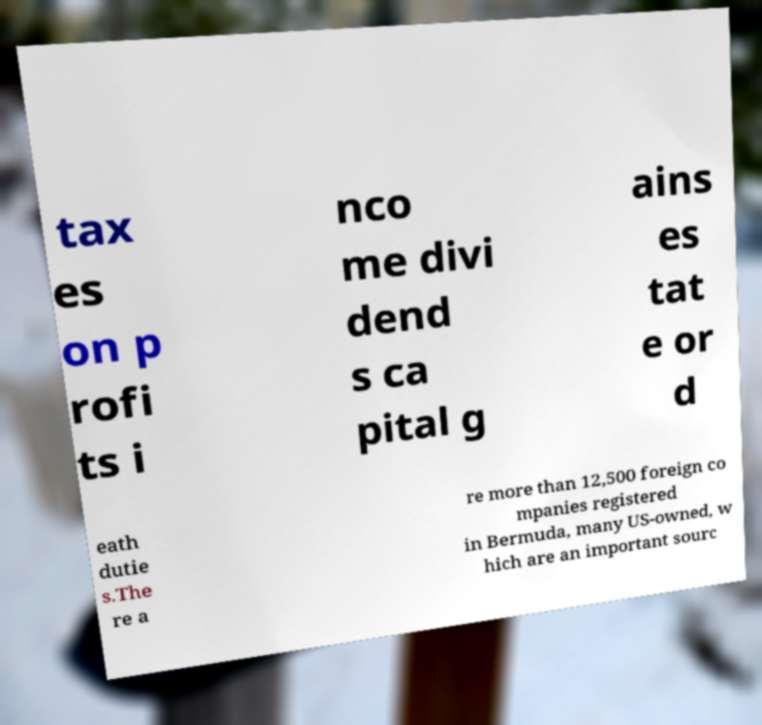Please identify and transcribe the text found in this image. tax es on p rofi ts i nco me divi dend s ca pital g ains es tat e or d eath dutie s.The re a re more than 12,500 foreign co mpanies registered in Bermuda, many US-owned, w hich are an important sourc 